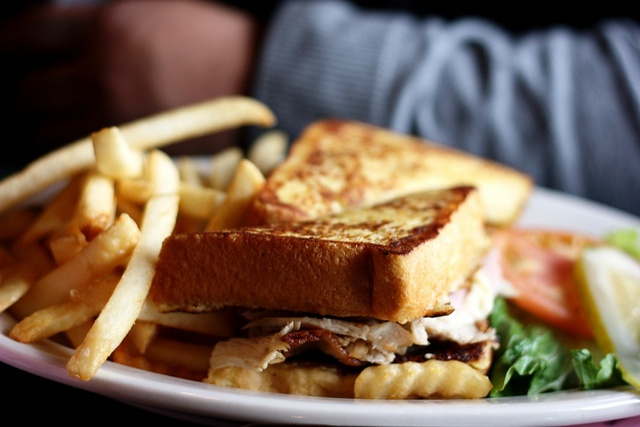Describe the objects in this image and their specific colors. I can see people in black, gray, and darkgray tones, sandwich in black, maroon, beige, and khaki tones, sandwich in black, tan, khaki, lightyellow, and brown tones, and broccoli in black, green, and darkgreen tones in this image. 